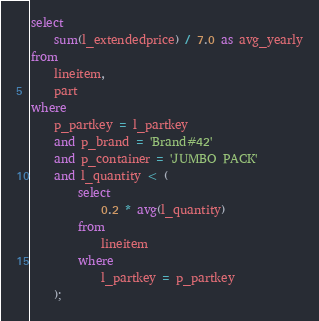<code> <loc_0><loc_0><loc_500><loc_500><_SQL_>select
    sum(l_extendedprice) / 7.0 as avg_yearly
from
    lineitem,
    part
where
    p_partkey = l_partkey
    and p_brand = 'Brand#42'
    and p_container = 'JUMBO PACK'
    and l_quantity < (
        select
            0.2 * avg(l_quantity)
        from
            lineitem
        where
            l_partkey = p_partkey
    );
</code> 